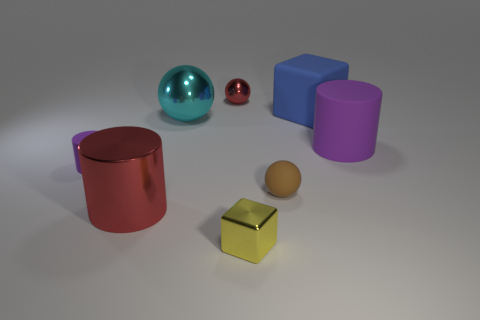There is a matte cylinder on the right side of the yellow metallic cube; what is its color?
Keep it short and to the point. Purple. Is the color of the big shiny ball the same as the big cylinder that is to the left of the large cyan metal sphere?
Offer a very short reply. No. Is the number of tiny yellow metal cubes less than the number of small gray rubber spheres?
Your response must be concise. No. Do the large metallic thing that is on the right side of the large red metallic thing and the metallic block have the same color?
Offer a very short reply. No. How many brown spheres are the same size as the yellow block?
Ensure brevity in your answer.  1. Are there any small cylinders that have the same color as the large shiny cylinder?
Provide a short and direct response. No. Is the material of the big red cylinder the same as the yellow thing?
Provide a succinct answer. Yes. What number of other objects are the same shape as the tiny purple matte thing?
Keep it short and to the point. 2. There is a tiny red thing that is the same material as the large cyan ball; what shape is it?
Your response must be concise. Sphere. There is a tiny ball that is in front of the purple rubber cylinder that is left of the metallic cylinder; what color is it?
Give a very brief answer. Brown. 